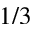Convert formula to latex. <formula><loc_0><loc_0><loc_500><loc_500>1 / 3</formula> 